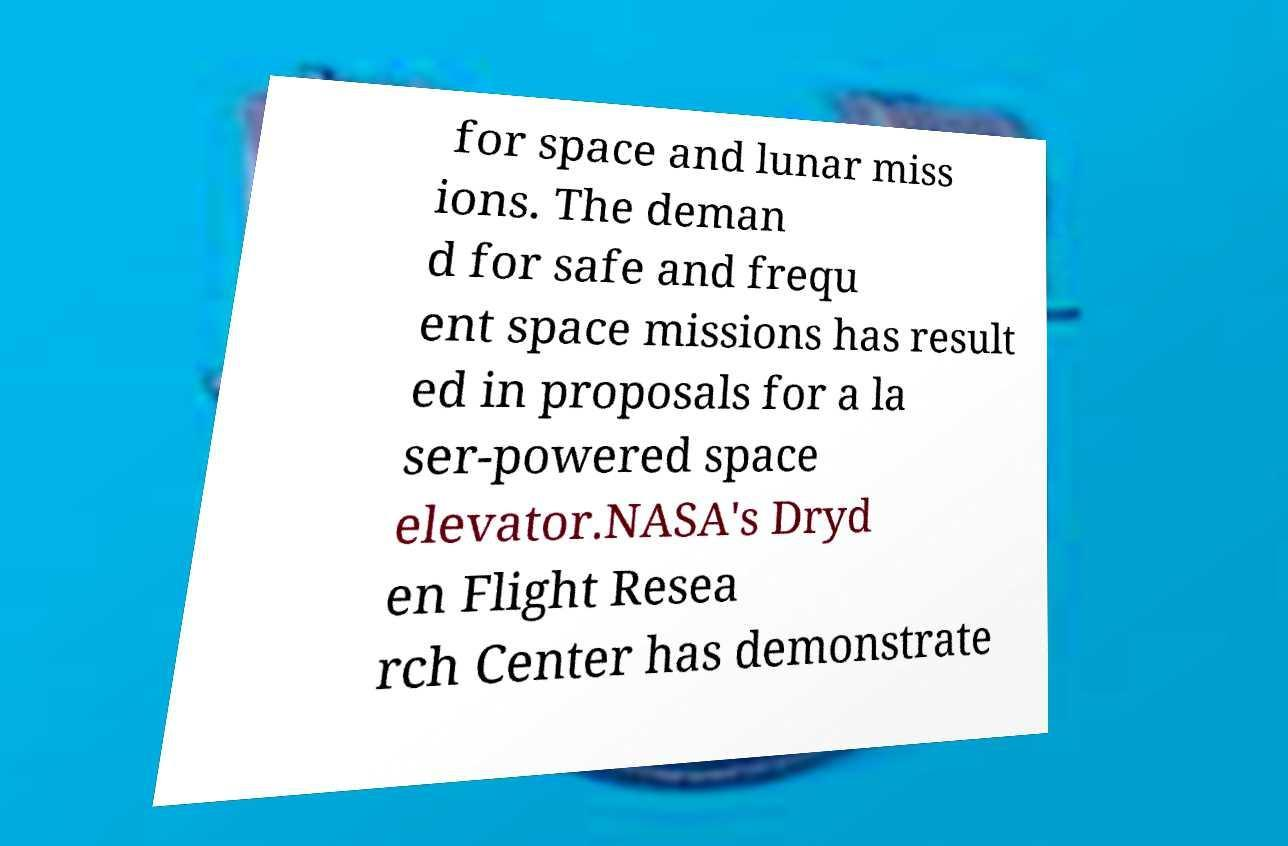Can you accurately transcribe the text from the provided image for me? for space and lunar miss ions. The deman d for safe and frequ ent space missions has result ed in proposals for a la ser-powered space elevator.NASA's Dryd en Flight Resea rch Center has demonstrate 